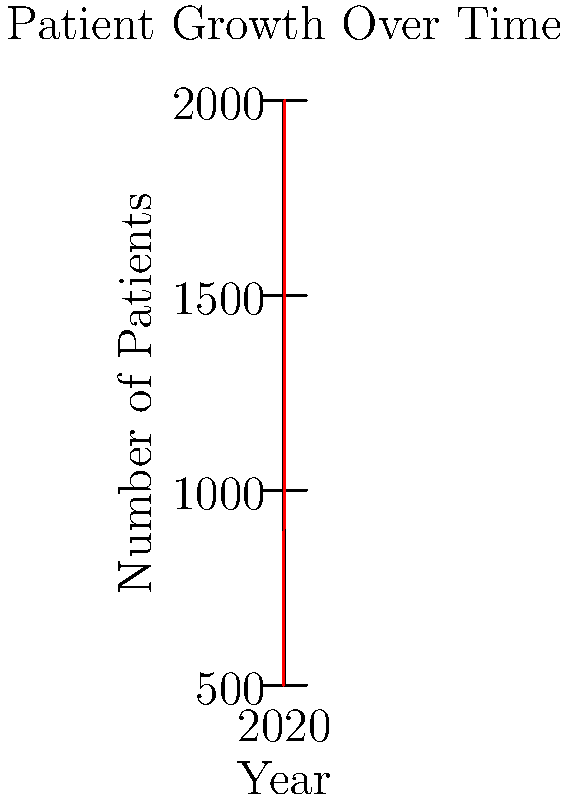Based on the graph showing patient growth over time, calculate the average year-over-year increase in patient numbers between 2018 and 2022. How might this trend impact your plans for expanding your dental practice? To calculate the average year-over-year increase in patient numbers:

1. Calculate total increase: 2000 (2022) - 500 (2018) = 1500 patients

2. Determine number of intervals: 2022 - 2018 = 4 years

3. Calculate average increase: 1500 / 4 = 375 patients per year

Impact on practice expansion plans:

1. Consistent growth indicates strong demand for dental services.
2. Average increase of 375 patients per year suggests need for additional staff and equipment.
3. May need to consider larger office space to accommodate growing patient base.
4. Financial projections should account for both increased revenue and expenses associated with growth.
5. Quality of care must be maintained despite rapid expansion.
Answer: 375 patients per year; necessitates careful planning for staff, equipment, and space to maintain quality care while accommodating growth. 